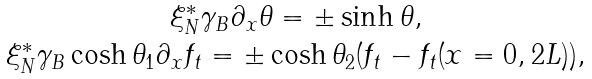Convert formula to latex. <formula><loc_0><loc_0><loc_500><loc_500>\begin{array} { c } \xi _ { N } ^ { * } \gamma _ { B } \partial _ { x } \theta = \pm \sinh \theta , \\ \xi _ { N } ^ { * } \gamma _ { B } \cosh \theta _ { 1 } \partial _ { x } f _ { t } = \pm \cosh \theta _ { 2 } ( f _ { t } - f _ { t } ( x = 0 , 2 L ) ) , \end{array}</formula> 